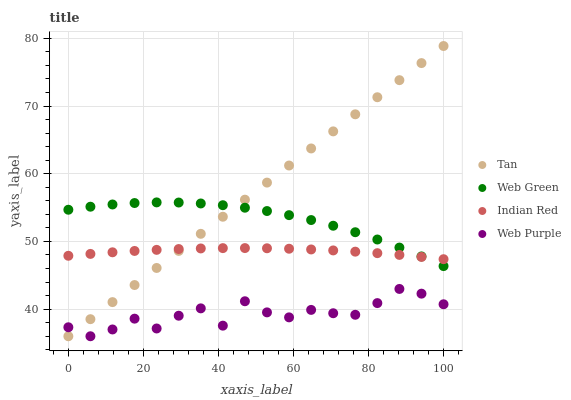Does Web Purple have the minimum area under the curve?
Answer yes or no. Yes. Does Tan have the maximum area under the curve?
Answer yes or no. Yes. Does Indian Red have the minimum area under the curve?
Answer yes or no. No. Does Indian Red have the maximum area under the curve?
Answer yes or no. No. Is Tan the smoothest?
Answer yes or no. Yes. Is Web Purple the roughest?
Answer yes or no. Yes. Is Indian Red the smoothest?
Answer yes or no. No. Is Indian Red the roughest?
Answer yes or no. No. Does Web Purple have the lowest value?
Answer yes or no. Yes. Does Indian Red have the lowest value?
Answer yes or no. No. Does Tan have the highest value?
Answer yes or no. Yes. Does Indian Red have the highest value?
Answer yes or no. No. Is Web Purple less than Indian Red?
Answer yes or no. Yes. Is Indian Red greater than Web Purple?
Answer yes or no. Yes. Does Web Purple intersect Tan?
Answer yes or no. Yes. Is Web Purple less than Tan?
Answer yes or no. No. Is Web Purple greater than Tan?
Answer yes or no. No. Does Web Purple intersect Indian Red?
Answer yes or no. No. 